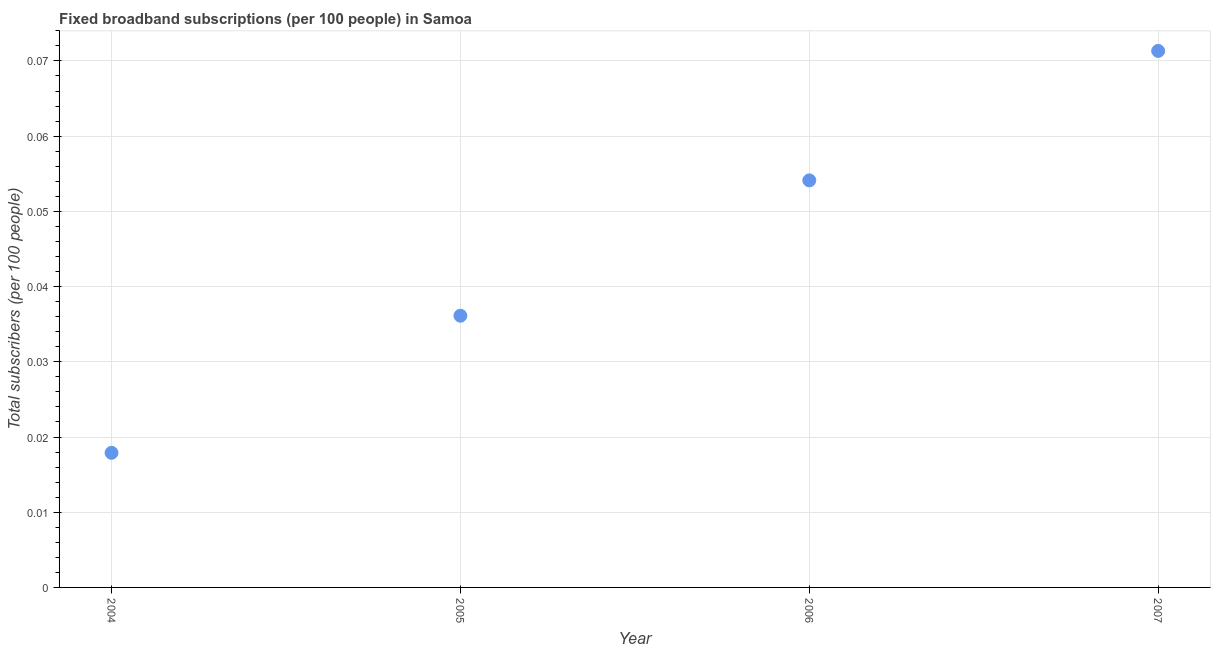What is the total number of fixed broadband subscriptions in 2005?
Ensure brevity in your answer.  0.04. Across all years, what is the maximum total number of fixed broadband subscriptions?
Provide a succinct answer. 0.07. Across all years, what is the minimum total number of fixed broadband subscriptions?
Keep it short and to the point. 0.02. In which year was the total number of fixed broadband subscriptions maximum?
Ensure brevity in your answer.  2007. What is the sum of the total number of fixed broadband subscriptions?
Give a very brief answer. 0.18. What is the difference between the total number of fixed broadband subscriptions in 2004 and 2007?
Offer a terse response. -0.05. What is the average total number of fixed broadband subscriptions per year?
Keep it short and to the point. 0.04. What is the median total number of fixed broadband subscriptions?
Ensure brevity in your answer.  0.05. In how many years, is the total number of fixed broadband subscriptions greater than 0.044 ?
Offer a very short reply. 2. What is the ratio of the total number of fixed broadband subscriptions in 2005 to that in 2007?
Give a very brief answer. 0.51. Is the total number of fixed broadband subscriptions in 2006 less than that in 2007?
Make the answer very short. Yes. What is the difference between the highest and the second highest total number of fixed broadband subscriptions?
Provide a short and direct response. 0.02. What is the difference between the highest and the lowest total number of fixed broadband subscriptions?
Offer a very short reply. 0.05. In how many years, is the total number of fixed broadband subscriptions greater than the average total number of fixed broadband subscriptions taken over all years?
Your answer should be very brief. 2. Does the total number of fixed broadband subscriptions monotonically increase over the years?
Your answer should be compact. Yes. How many dotlines are there?
Keep it short and to the point. 1. What is the difference between two consecutive major ticks on the Y-axis?
Ensure brevity in your answer.  0.01. Are the values on the major ticks of Y-axis written in scientific E-notation?
Your answer should be compact. No. Does the graph contain grids?
Your answer should be compact. Yes. What is the title of the graph?
Provide a succinct answer. Fixed broadband subscriptions (per 100 people) in Samoa. What is the label or title of the X-axis?
Your answer should be very brief. Year. What is the label or title of the Y-axis?
Keep it short and to the point. Total subscribers (per 100 people). What is the Total subscribers (per 100 people) in 2004?
Your answer should be compact. 0.02. What is the Total subscribers (per 100 people) in 2005?
Make the answer very short. 0.04. What is the Total subscribers (per 100 people) in 2006?
Make the answer very short. 0.05. What is the Total subscribers (per 100 people) in 2007?
Make the answer very short. 0.07. What is the difference between the Total subscribers (per 100 people) in 2004 and 2005?
Provide a short and direct response. -0.02. What is the difference between the Total subscribers (per 100 people) in 2004 and 2006?
Your answer should be compact. -0.04. What is the difference between the Total subscribers (per 100 people) in 2004 and 2007?
Provide a short and direct response. -0.05. What is the difference between the Total subscribers (per 100 people) in 2005 and 2006?
Offer a very short reply. -0.02. What is the difference between the Total subscribers (per 100 people) in 2005 and 2007?
Your answer should be very brief. -0.04. What is the difference between the Total subscribers (per 100 people) in 2006 and 2007?
Ensure brevity in your answer.  -0.02. What is the ratio of the Total subscribers (per 100 people) in 2004 to that in 2005?
Ensure brevity in your answer.  0.49. What is the ratio of the Total subscribers (per 100 people) in 2004 to that in 2006?
Offer a terse response. 0.33. What is the ratio of the Total subscribers (per 100 people) in 2004 to that in 2007?
Offer a very short reply. 0.25. What is the ratio of the Total subscribers (per 100 people) in 2005 to that in 2006?
Offer a terse response. 0.67. What is the ratio of the Total subscribers (per 100 people) in 2005 to that in 2007?
Your response must be concise. 0.51. What is the ratio of the Total subscribers (per 100 people) in 2006 to that in 2007?
Ensure brevity in your answer.  0.76. 